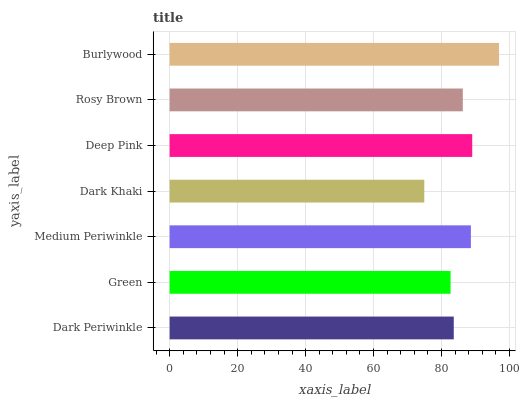Is Dark Khaki the minimum?
Answer yes or no. Yes. Is Burlywood the maximum?
Answer yes or no. Yes. Is Green the minimum?
Answer yes or no. No. Is Green the maximum?
Answer yes or no. No. Is Dark Periwinkle greater than Green?
Answer yes or no. Yes. Is Green less than Dark Periwinkle?
Answer yes or no. Yes. Is Green greater than Dark Periwinkle?
Answer yes or no. No. Is Dark Periwinkle less than Green?
Answer yes or no. No. Is Rosy Brown the high median?
Answer yes or no. Yes. Is Rosy Brown the low median?
Answer yes or no. Yes. Is Burlywood the high median?
Answer yes or no. No. Is Deep Pink the low median?
Answer yes or no. No. 